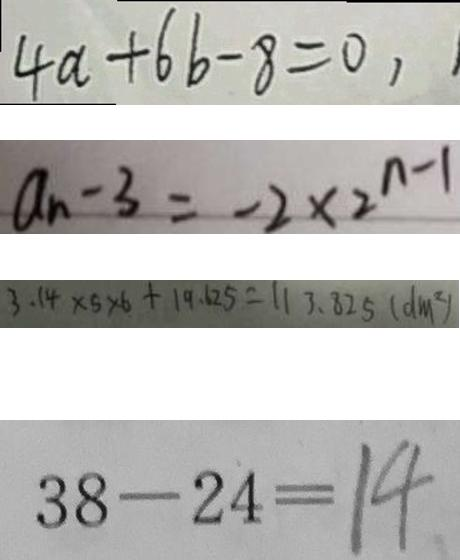Convert formula to latex. <formula><loc_0><loc_0><loc_500><loc_500>4 a + 6 b - 8 = 0 , 
 a _ { n } - 3 = - 2 \times 2 ^ { n - 1 } 
 3 . 1 4 \times 5 \times 6 + 1 9 . 6 2 5 = 1 1 3 . 8 2 5 ( d m ^ { 2 } ) 
 3 8 - 2 4 = 1 4</formula> 